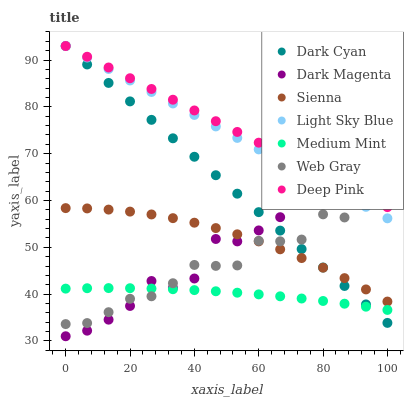Does Medium Mint have the minimum area under the curve?
Answer yes or no. Yes. Does Deep Pink have the maximum area under the curve?
Answer yes or no. Yes. Does Web Gray have the minimum area under the curve?
Answer yes or no. No. Does Web Gray have the maximum area under the curve?
Answer yes or no. No. Is Dark Cyan the smoothest?
Answer yes or no. Yes. Is Web Gray the roughest?
Answer yes or no. Yes. Is Dark Magenta the smoothest?
Answer yes or no. No. Is Dark Magenta the roughest?
Answer yes or no. No. Does Dark Magenta have the lowest value?
Answer yes or no. Yes. Does Web Gray have the lowest value?
Answer yes or no. No. Does Dark Cyan have the highest value?
Answer yes or no. Yes. Does Web Gray have the highest value?
Answer yes or no. No. Is Medium Mint less than Light Sky Blue?
Answer yes or no. Yes. Is Deep Pink greater than Sienna?
Answer yes or no. Yes. Does Light Sky Blue intersect Dark Magenta?
Answer yes or no. Yes. Is Light Sky Blue less than Dark Magenta?
Answer yes or no. No. Is Light Sky Blue greater than Dark Magenta?
Answer yes or no. No. Does Medium Mint intersect Light Sky Blue?
Answer yes or no. No. 